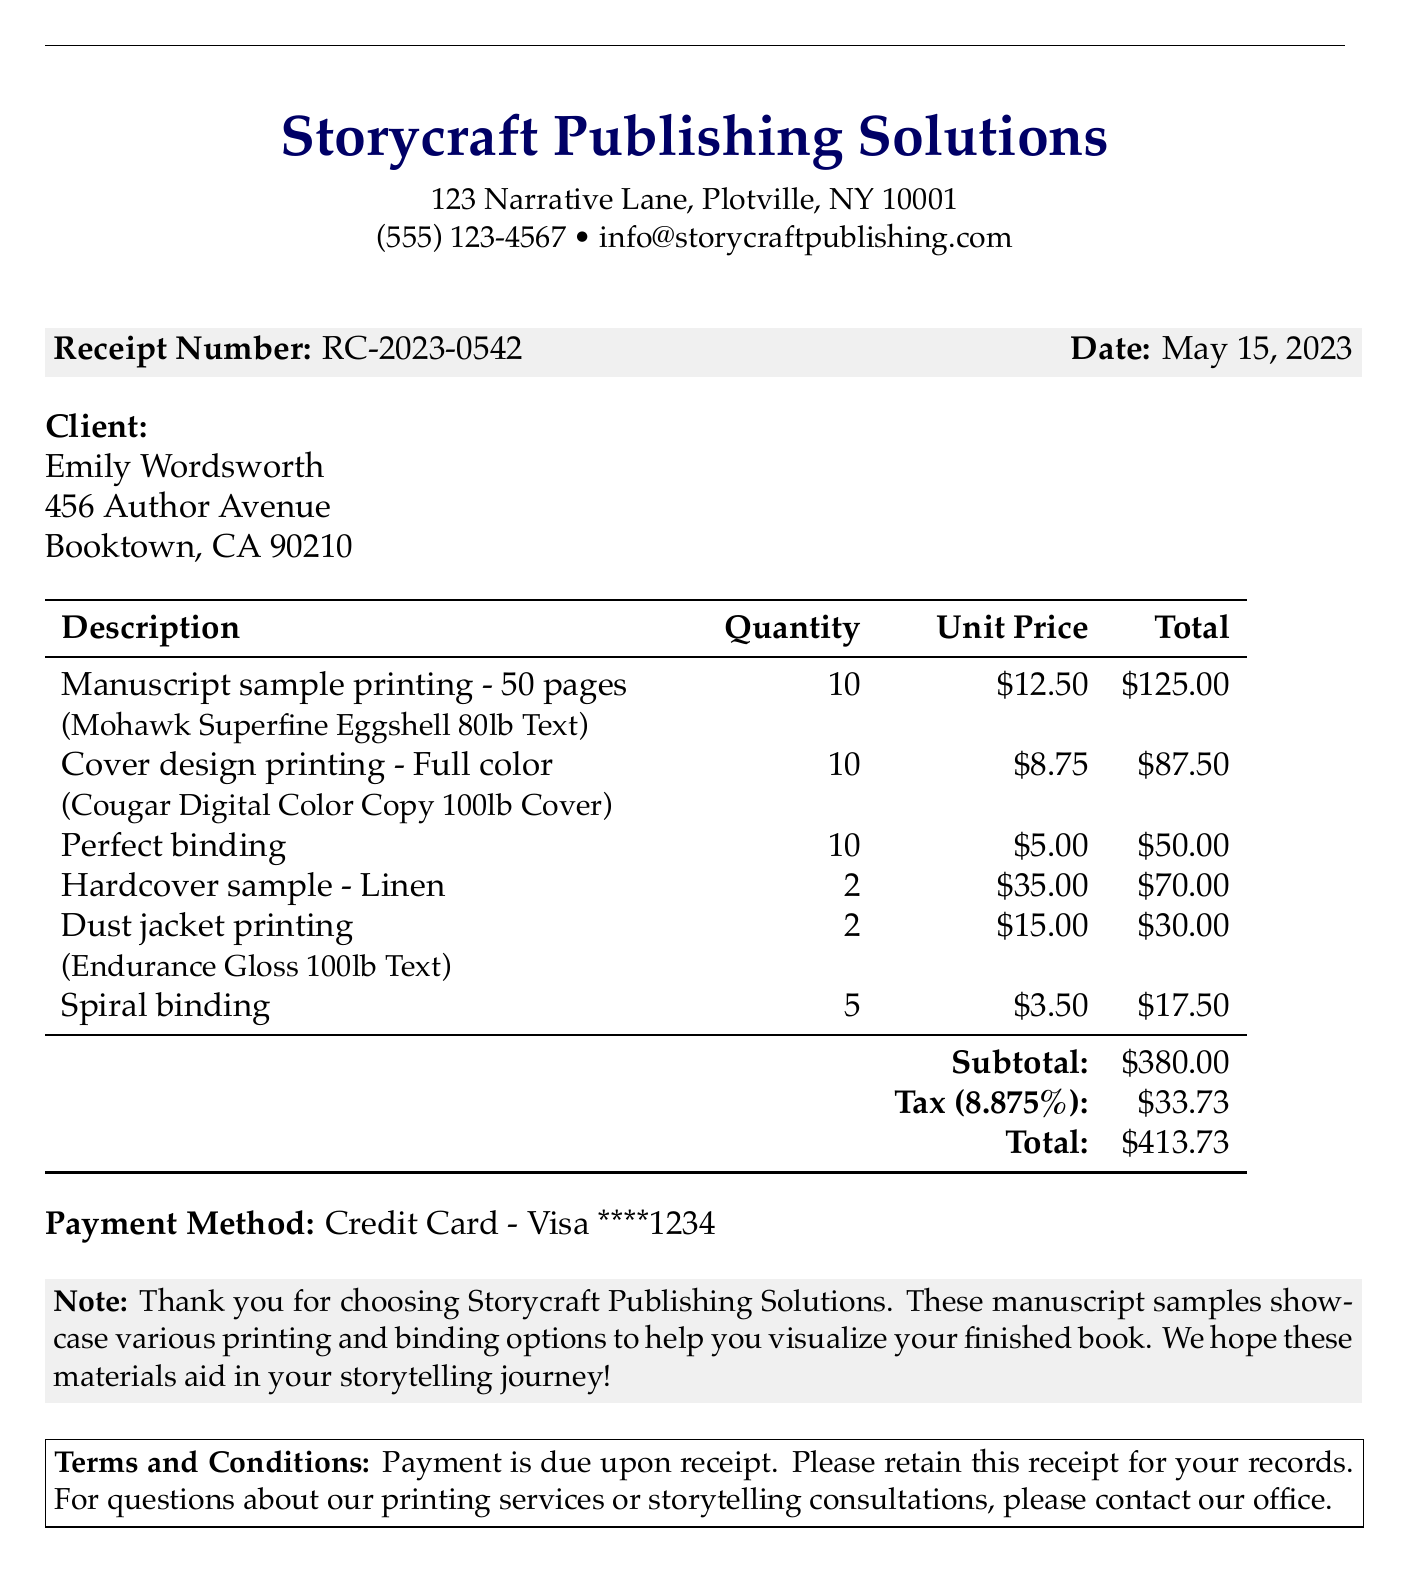What is the company name? The company name is provided at the top of the document.
Answer: Storycraft Publishing Solutions What is the receipt number? The receipt number is listed in a highlighted box on the document.
Answer: RC-2023-0542 What type of paper is used for manuscript printing? The type of paper used is specified in the services section.
Answer: Mohawk Superfine Eggshell 80lb Text How many pages are included in the manuscript sample printing? The number of pages is mentioned in the description of manuscript sample printing.
Answer: 50 pages What is the total cost before tax? The subtotal before tax is displayed in the total calculation section.
Answer: $380.00 What is the tax rate applied to the receipt? The tax rate is provided in the tax calculation section of the document.
Answer: 8.875% What binding options are available in the receipt? The binding options listed in the services section must be considered.
Answer: Perfect binding, Spiral binding How many units of hardcover samples were ordered? The quantity of hardcover samples is listed in the services section.
Answer: 2 What is the payment method used for this transaction? The payment method can be found toward the bottom of the receipt.
Answer: Credit Card - Visa ****1234 